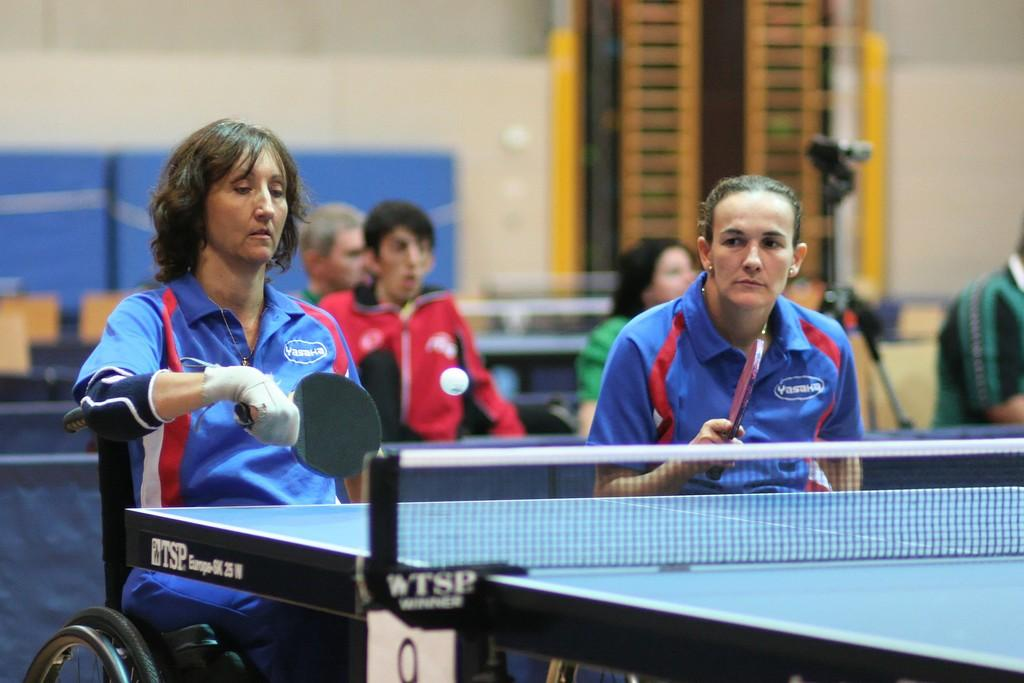What is the activity being performed by the two people in the image? The two people in the image are sitting and playing table tennis. What is the physical condition of the two people in the image? They are physically handicapped. Can you describe the setting in which the activity is taking place? There are additional people sitting in the background. What type of map can be seen on the table in the image? There is no map present in the image; it features two physically handicapped people playing table tennis with additional people sitting in the background. 